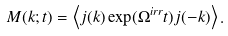Convert formula to latex. <formula><loc_0><loc_0><loc_500><loc_500>M ( k ; t ) = \left < j ( k ) \exp ( \Omega ^ { i r r } t ) j ( - k ) \right > .</formula> 